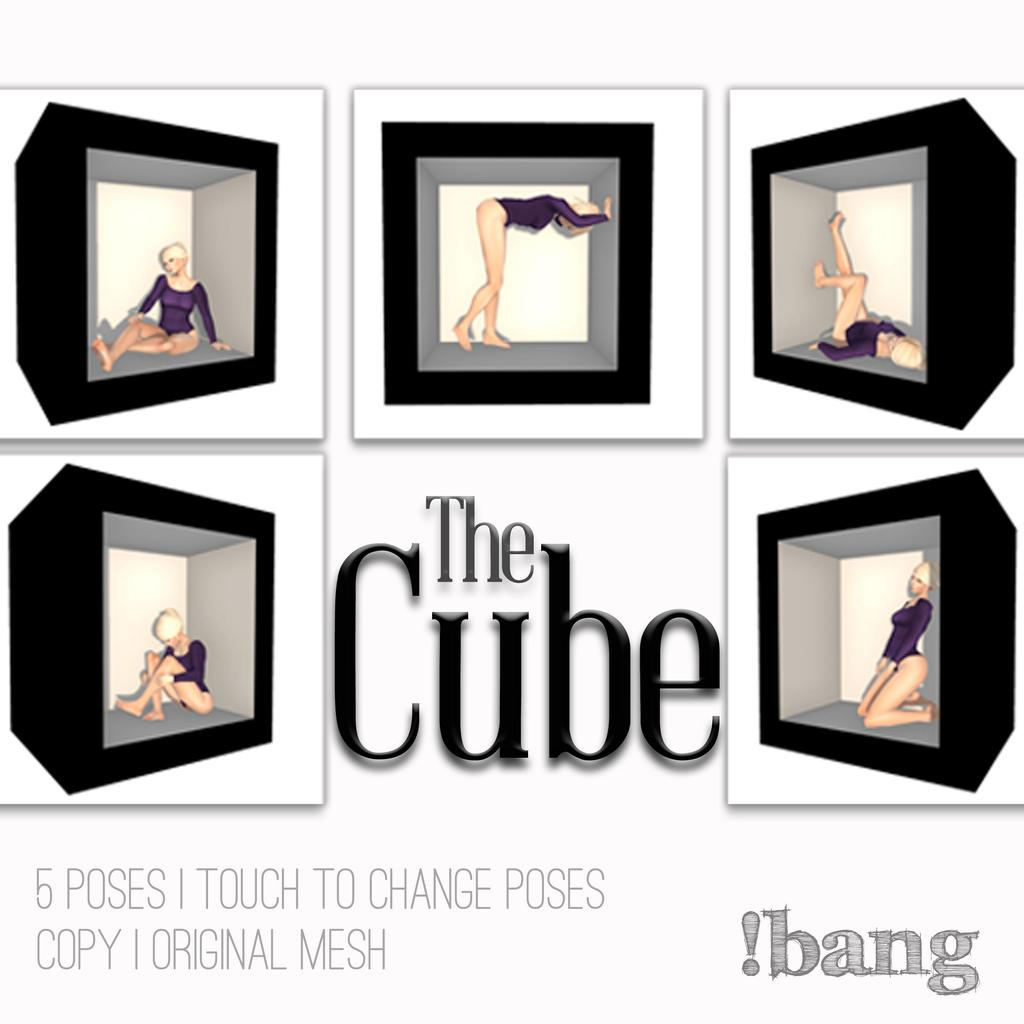<image>
Present a compact description of the photo's key features. A poster with the The cube written in large letters. 